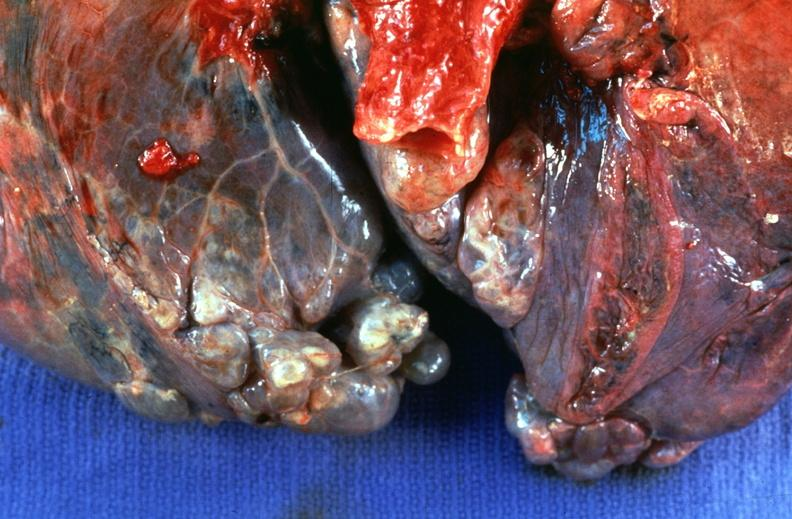does basal skull fracture show lung, emphysema severe with bullae?
Answer the question using a single word or phrase. No 